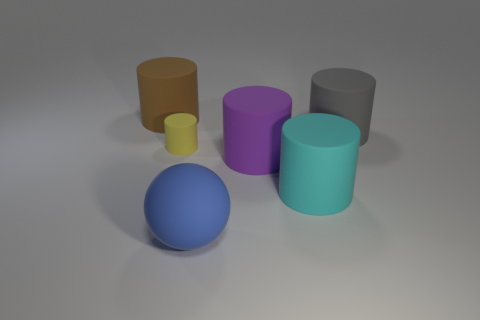If this were a scene from a child's learning game, what kind of questions might be asked to engage with the content? Questions could range from 'Can you identify all the shapes and colors?' to 'Which cylinder is the tallest?' or 'What is the color of the object that looks like a ball?' These questions could help children learn about sizes, colors, and spatial relationships. 